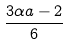Convert formula to latex. <formula><loc_0><loc_0><loc_500><loc_500>\frac { 3 \alpha a - 2 } { 6 }</formula> 